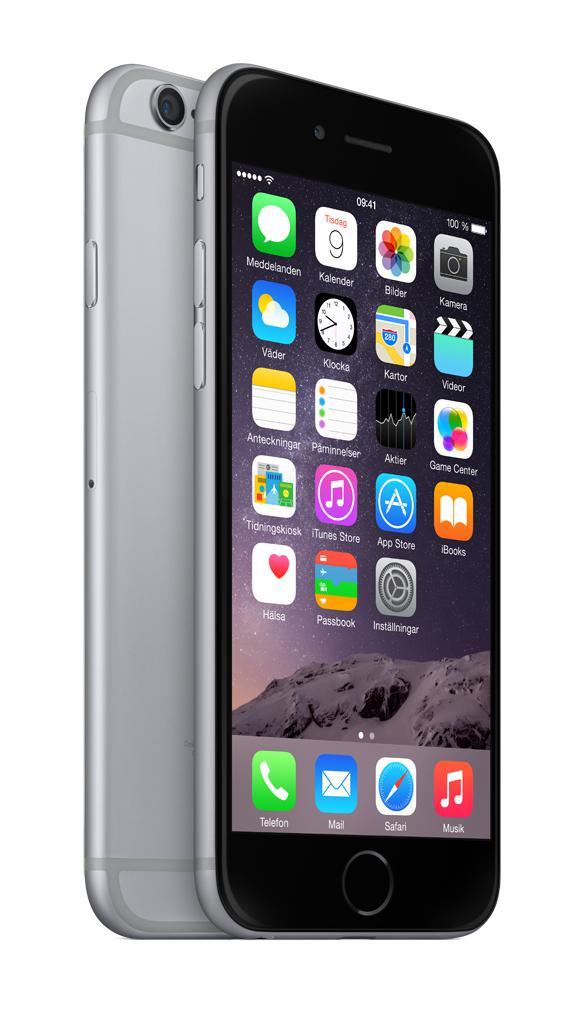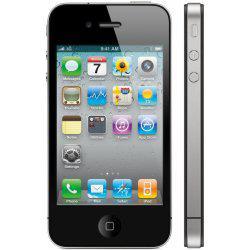The first image is the image on the left, the second image is the image on the right. Analyze the images presented: Is the assertion "The back of a phone is completely visible." valid? Answer yes or no. No. The first image is the image on the left, the second image is the image on the right. Evaluate the accuracy of this statement regarding the images: "There is  total of four phones with the right side having more.". Is it true? Answer yes or no. No. 